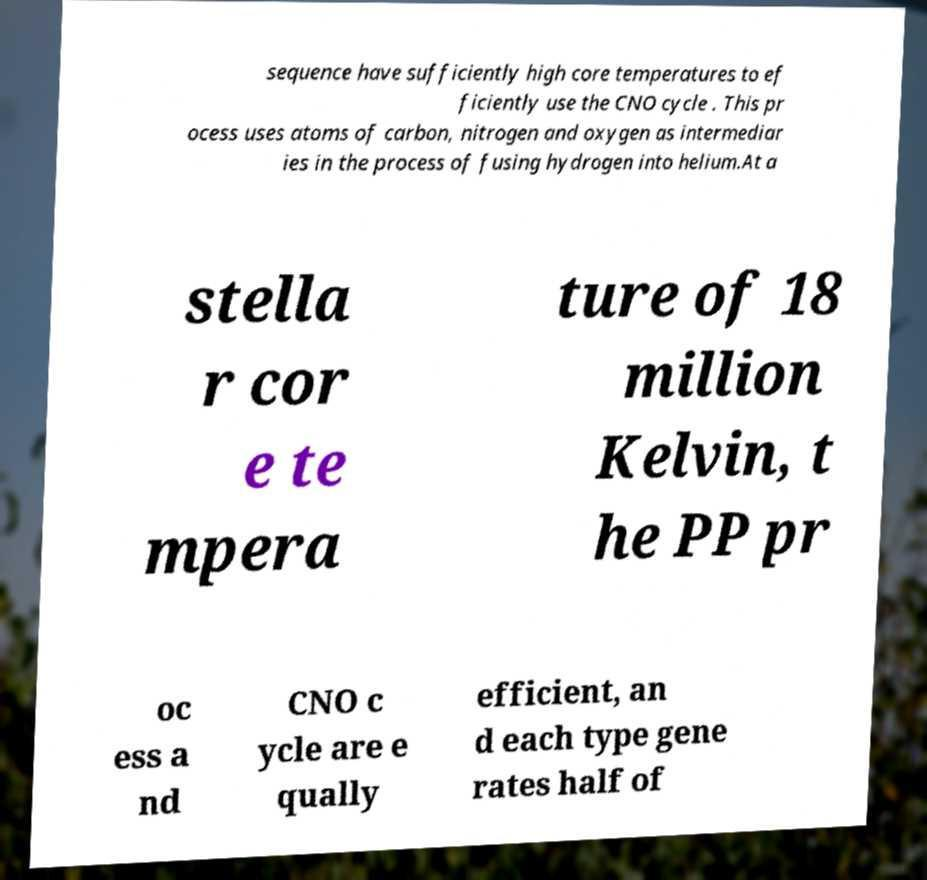Can you read and provide the text displayed in the image?This photo seems to have some interesting text. Can you extract and type it out for me? sequence have sufficiently high core temperatures to ef ficiently use the CNO cycle . This pr ocess uses atoms of carbon, nitrogen and oxygen as intermediar ies in the process of fusing hydrogen into helium.At a stella r cor e te mpera ture of 18 million Kelvin, t he PP pr oc ess a nd CNO c ycle are e qually efficient, an d each type gene rates half of 